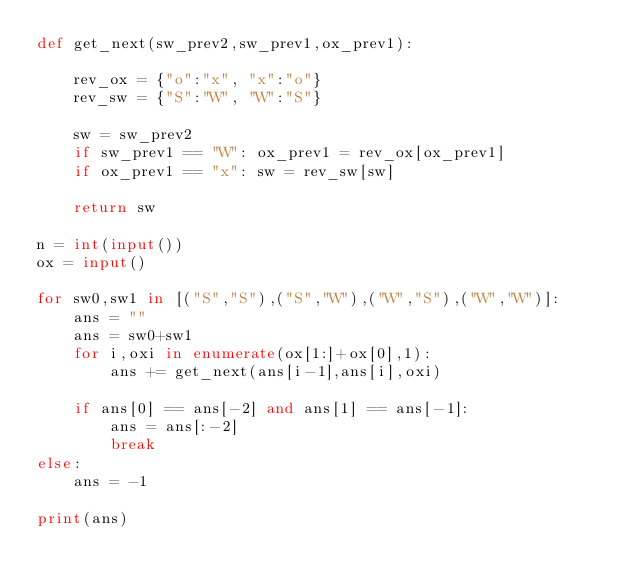Convert code to text. <code><loc_0><loc_0><loc_500><loc_500><_Python_>def get_next(sw_prev2,sw_prev1,ox_prev1):
    
    rev_ox = {"o":"x", "x":"o"}
    rev_sw = {"S":"W", "W":"S"}
    
    sw = sw_prev2
    if sw_prev1 == "W": ox_prev1 = rev_ox[ox_prev1]
    if ox_prev1 == "x": sw = rev_sw[sw]
    
    return sw

n = int(input())
ox = input()

for sw0,sw1 in [("S","S"),("S","W"),("W","S"),("W","W")]:
    ans = ""
    ans = sw0+sw1
    for i,oxi in enumerate(ox[1:]+ox[0],1):
        ans += get_next(ans[i-1],ans[i],oxi)
    
    if ans[0] == ans[-2] and ans[1] == ans[-1]:
        ans = ans[:-2]
        break
else:
    ans = -1

print(ans)</code> 